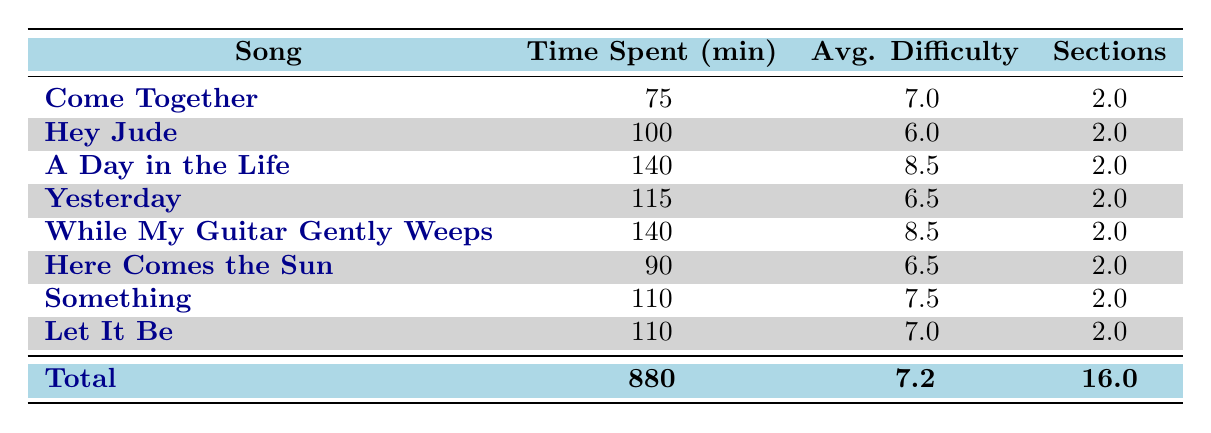What is the total time spent on rehearsals for the song "Hey Jude"? Looking at the table, the time spent for "Hey Jude" is listed as 100 minutes.
Answer: 100 Which song has the highest average difficulty level? By scanning the average difficulty column, both "A Day in the Life" and "While My Guitar Gently Weeps" have the highest average difficulty of 8.5.
Answer: A Day in the Life, While My Guitar Gently Weeps What is the average time spent across all songs? To find the average, we take the total time spent of 880 minutes and divide it by the number of songs, which is 8. Thus, 880/8 = 110.
Answer: 110 Is the average difficulty of songs equal to or greater than 7? The average difficulty is indicated as 7.2 in the table, which is indeed greater than 7.
Answer: Yes What is the total time spent on saxophone sections? From the table, if we enumerate the time spent for all saxophone sections: 45 (Come Together) + 60 (Hey Jude) + 90 (A Day in the Life) + 75 (Yesterday) + 80 (While My Guitar Gently Weeps) + 55 (Here Comes the Sun) + 70 (Something) + 65 (Let It Be) equals 520.
Answer: 520 What is the average time spent on vocal arrangements across all songs? The table shows only one entry for vocal arrangements, which is 40 minutes for "Hey Jude." Therefore, the average time spent on vocal arrangements is simply 40.
Answer: 40 How many sections are there for the song "Let It Be"? Referring to the table, "Let It Be" is listed as having 2 sections.
Answer: 2 Which song has the lowest time spent for a section? The time listed for sections in the table shows that the lowest time is 30 minutes for the "Rhythm Section" of "Come Together."
Answer: Come Together How much more time is spent on rehearsals for "A Day in the Life" compared to "Let It Be"? The time spent on "A Day in the Life" is 140 minutes and on "Let It Be" is 110 minutes. Thus, 140 - 110 = 30 minutes more is spent on "A Day in the Life."
Answer: 30 